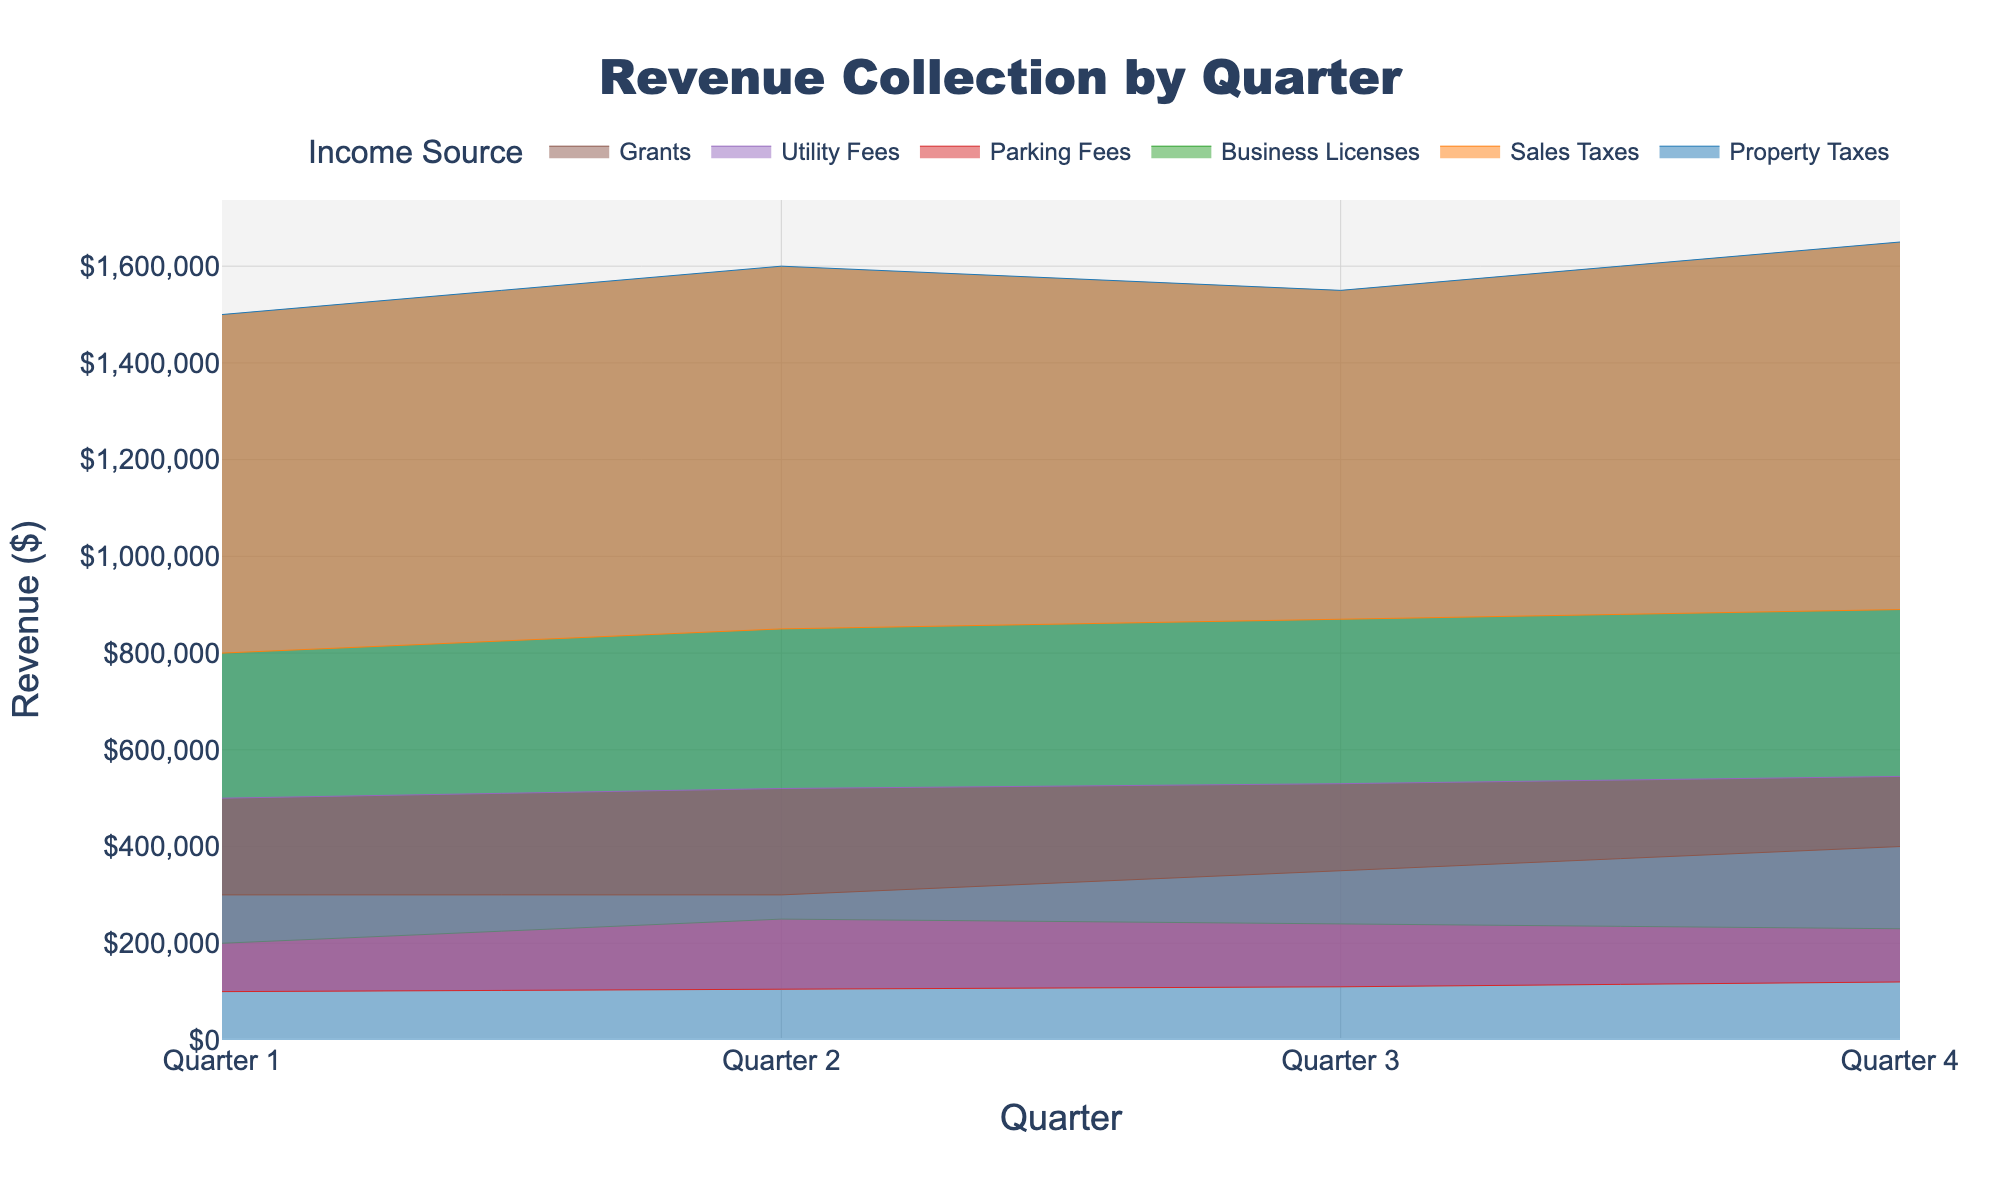What is the title of the figure? The title is usually displayed at the top of the chart and is highly visible and often in a larger font size. Here, the title is "Revenue Collection by Quarter".
Answer: Revenue Collection by Quarter What is the highest revenue source in Quarter 4? By visually inspecting the heights of the areas on the chart and focusing on Quarter 4, the highest income source is the area with the largest height. The tallest by visual inspection is "Property Taxes".
Answer: Property Taxes How does the revenue from Sales Taxes change from Quarter 1 to Quarter 4? By following the Sales Taxes line on the figure from left (Quarter 1) to right (Quarter 4), you see the line's direction moving upward sequentially. This indicates an increasing revenue from $800,000 in Quarter 1 to $890,000 in Quarter 4.
Answer: Increases Which income source has the least fluctuation across the quarters? Least fluctuation means the line should remain relatively flat. Observing each line, the flattest one appears to be for Grants, as the values change from $300,000 to $400,000.
Answer: Grants What is the total revenue collected from Business Licenses in all four quarters combined? Sum the values for Business Licenses across all quarters: $200,000 (Q1) + $250,000 (Q2) + $240,000 (Q3) + $230,000 (Q4) = $920,000
Answer: $920,000 Which quarter has the highest overall revenue collection, considering all sources combined? Sum the revenue of all sources for each quarter and compare: 
- Q1: $1500000 + $800000 + $200000 + $100000 + $500000 + $300000 = $3,400,000 
- Q2: $1600000 + $850000 + $250000 + $105000 + $520000 + $300000 = $3,720,000 
- Q3: $1550000 + $870000 + $240000 + $110000 + $530000 + $350000 = $3,730,000 
- Q4: $1650000 + $890000 + $230000 + $120000 + $545000 + $400000 = $3,820,000 
The highest total is in Quarter 4 with $3,820,000.
Answer: Quarter 4 Which income source shows a decrease in revenue from Quarter 3 to Quarter 4? By comparing the values visually from Quarter 3 to Quarter 4 and noting any downward slopes, Business Licenses decrease from $240,000 to $230,000.
Answer: Business Licenses By how much does the revenue from Property Taxes increase from Quarter 1 to Quarter 2? The revenue from Property Taxes at Quarter 1 is $1,500,000 and at Quarter 2 is $1,600,000. The difference is $1,600,000 - $1,500,000 = $100,000.
Answer: $100,000 